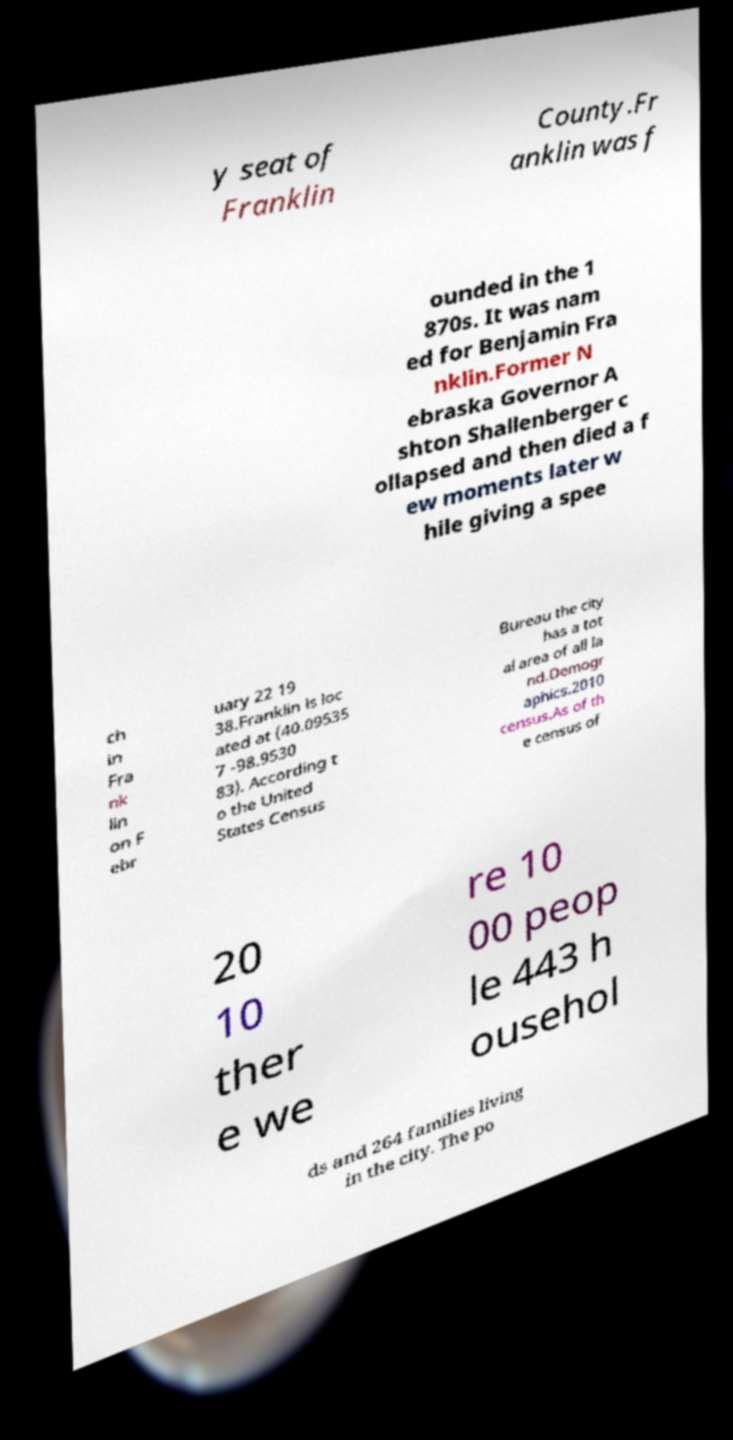Could you assist in decoding the text presented in this image and type it out clearly? y seat of Franklin County.Fr anklin was f ounded in the 1 870s. It was nam ed for Benjamin Fra nklin.Former N ebraska Governor A shton Shallenberger c ollapsed and then died a f ew moments later w hile giving a spee ch in Fra nk lin on F ebr uary 22 19 38.Franklin is loc ated at (40.09535 7 -98.9530 83). According t o the United States Census Bureau the city has a tot al area of all la nd.Demogr aphics.2010 census.As of th e census of 20 10 ther e we re 10 00 peop le 443 h ousehol ds and 264 families living in the city. The po 